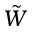<formula> <loc_0><loc_0><loc_500><loc_500>\tilde { W }</formula> 